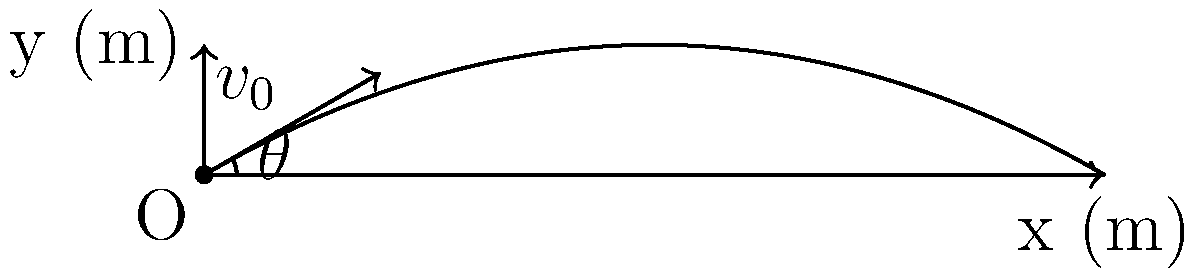A projectile is launched from ground level with an initial velocity of 50 m/s at an angle of 30° above the horizontal. Assuming negligible air resistance, calculate the maximum height reached by the projectile. Use g = 9.8 m/s² for the acceleration due to gravity. To solve this problem, we'll follow these steps:

1) First, we need to find the vertical component of the initial velocity:
   $v_{0y} = v_0 \sin\theta = 50 \sin(30°) = 25$ m/s

2) The maximum height is reached when the vertical velocity becomes zero. We can use the equation:
   $v_y^2 = v_{0y}^2 - 2gy$
   Where $v_y = 0$ at the highest point, so:
   $0 = v_{0y}^2 - 2gy_{max}$

3) Rearranging this equation:
   $y_{max} = \frac{v_{0y}^2}{2g}$

4) Now we can substitute our known values:
   $y_{max} = \frac{(25 \text{ m/s})^2}{2(9.8 \text{ m/s}^2)}$

5) Calculating:
   $y_{max} = \frac{625 \text{ m}^2/\text{s}^2}{19.6 \text{ m}/\text{s}^2} = 31.89$ m

Therefore, the maximum height reached by the projectile is approximately 31.89 meters.
Answer: 31.89 m 